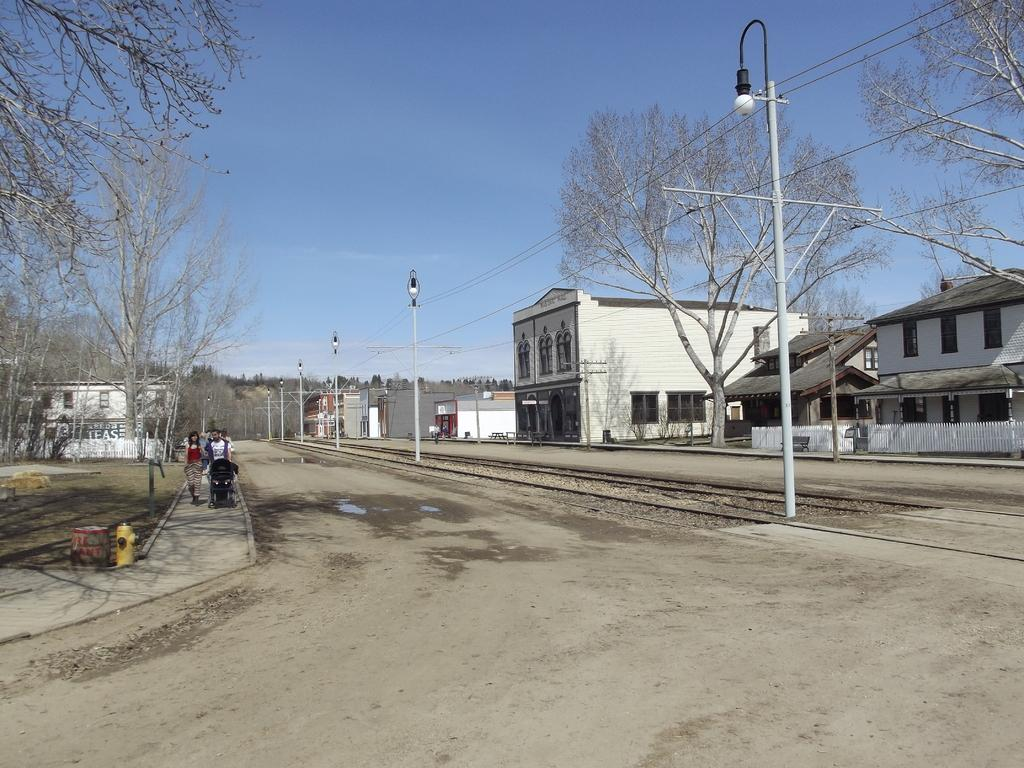What is happening in the foreground of the image? There is a group of people on the road in the foreground. What type of lighting is present in the image? Street lights are present in the image. What else can be seen in the image besides the people and street lights? Wires, houses, buildings, trees, and the sky are visible in the image. Can you describe the time of day when the image was taken? The image was taken during the day. What type of underwear is hanging on the clothesline in the image? There is no clothesline or underwear present in the image. How many cars are parked on the street in the image? There are no cars visible in the image; only a group of people, street lights, wires, houses, buildings, trees, and the sky are present. 